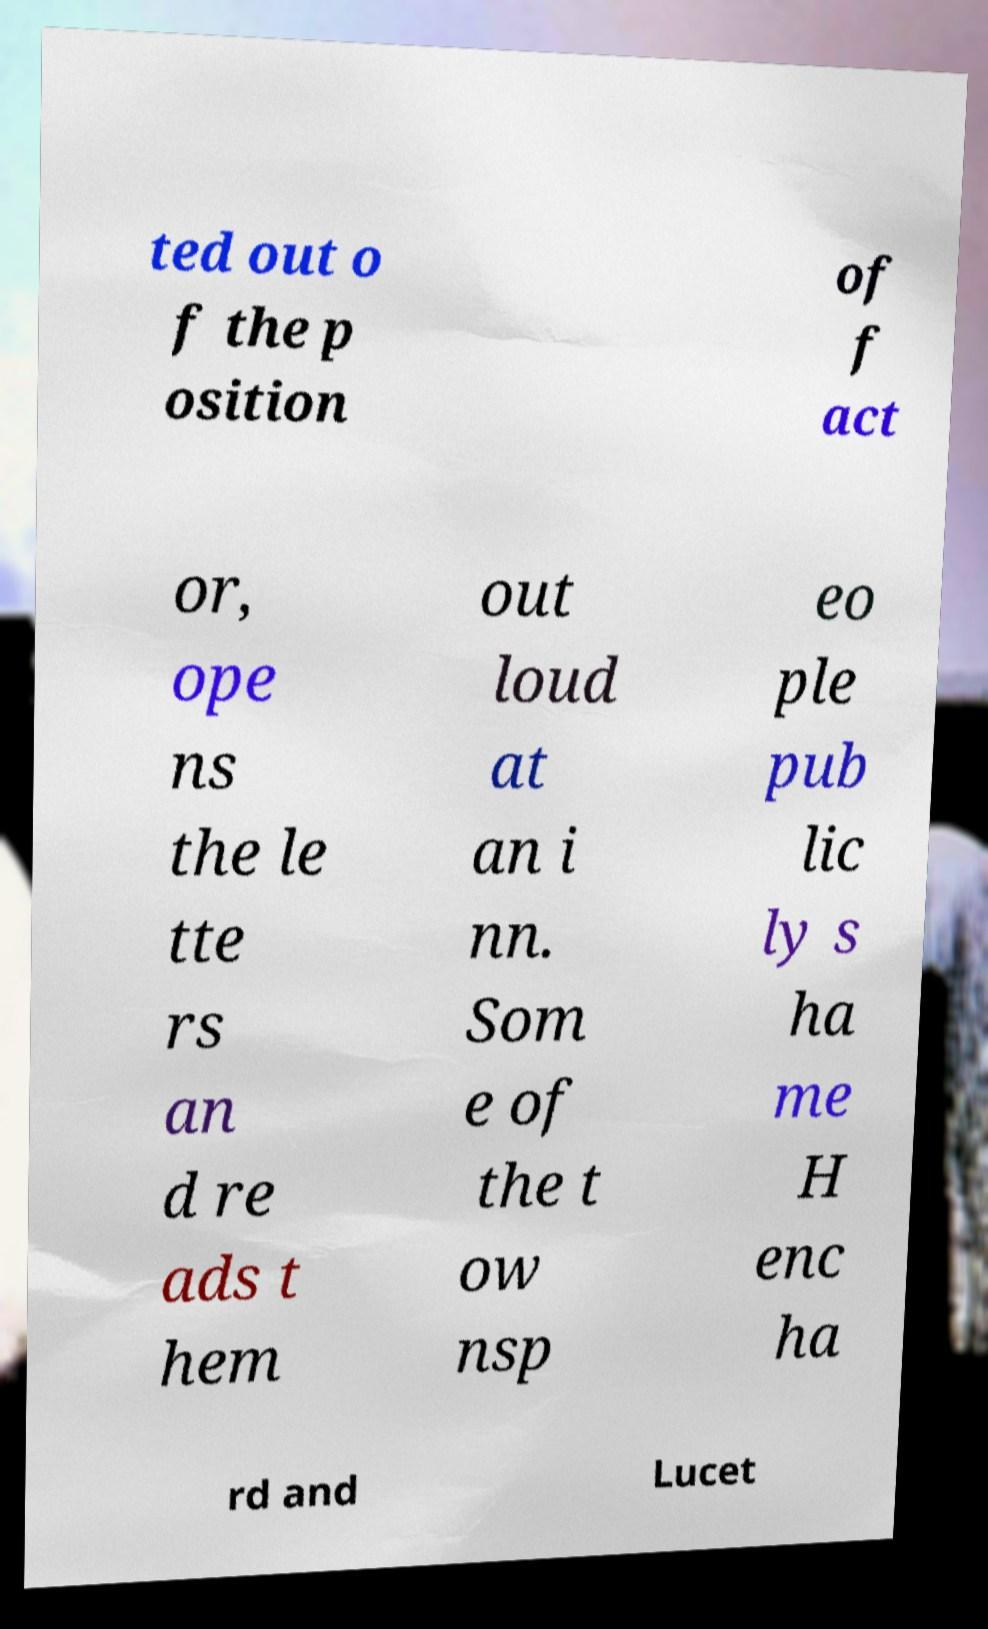Can you accurately transcribe the text from the provided image for me? ted out o f the p osition of f act or, ope ns the le tte rs an d re ads t hem out loud at an i nn. Som e of the t ow nsp eo ple pub lic ly s ha me H enc ha rd and Lucet 